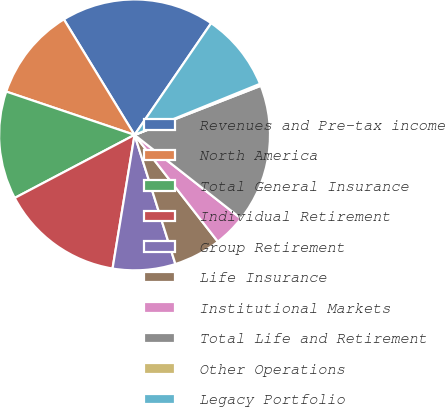Convert chart. <chart><loc_0><loc_0><loc_500><loc_500><pie_chart><fcel>Revenues and Pre-tax income<fcel>North America<fcel>Total General Insurance<fcel>Individual Retirement<fcel>Group Retirement<fcel>Life Insurance<fcel>Institutional Markets<fcel>Total Life and Retirement<fcel>Other Operations<fcel>Legacy Portfolio<nl><fcel>18.3%<fcel>11.08%<fcel>12.89%<fcel>14.69%<fcel>7.47%<fcel>5.67%<fcel>3.86%<fcel>16.5%<fcel>0.25%<fcel>9.28%<nl></chart> 